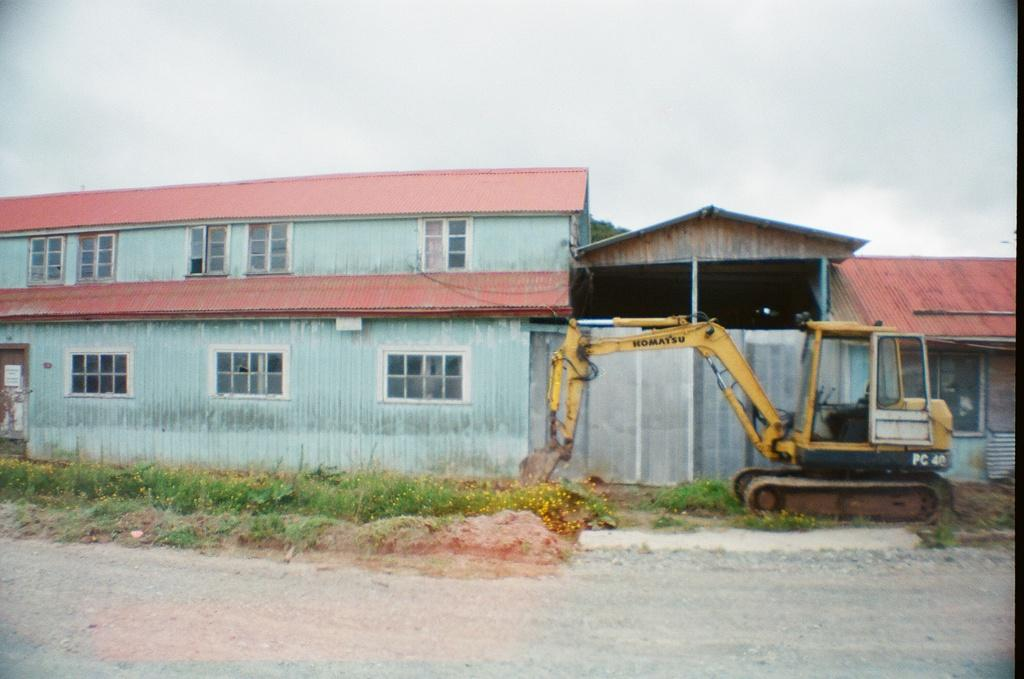What type of structures can be seen in the image? There are houses and a shed in the image. What is the large machine-like object in the image? There is a crane in the image. What is the surface on which the structures are built? The ground is visible in the image. What type of vegetation is present in the image? There is grass and plants in the image. What part of the natural environment is visible in the image? The sky is visible in the image. What type of news can be heard coming from the houses in the image? There is no indication of any news or sounds coming from the houses in the image, so it's not possible to determine what, if any, news might be heard. 